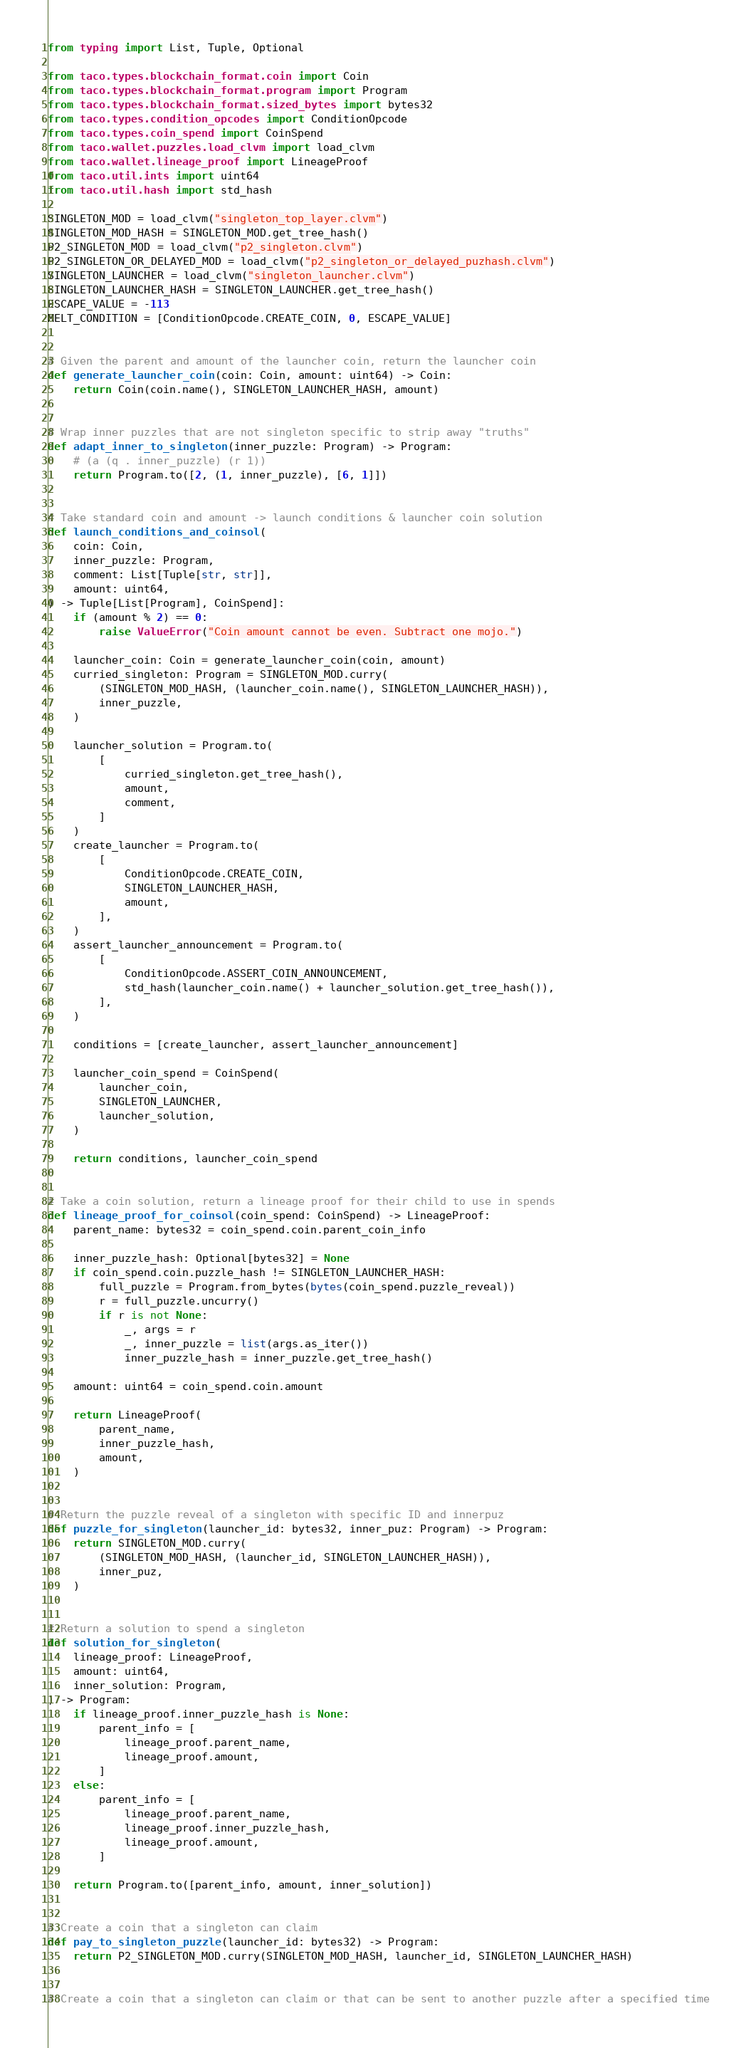Convert code to text. <code><loc_0><loc_0><loc_500><loc_500><_Python_>from typing import List, Tuple, Optional

from taco.types.blockchain_format.coin import Coin
from taco.types.blockchain_format.program import Program
from taco.types.blockchain_format.sized_bytes import bytes32
from taco.types.condition_opcodes import ConditionOpcode
from taco.types.coin_spend import CoinSpend
from taco.wallet.puzzles.load_clvm import load_clvm
from taco.wallet.lineage_proof import LineageProof
from taco.util.ints import uint64
from taco.util.hash import std_hash

SINGLETON_MOD = load_clvm("singleton_top_layer.clvm")
SINGLETON_MOD_HASH = SINGLETON_MOD.get_tree_hash()
P2_SINGLETON_MOD = load_clvm("p2_singleton.clvm")
P2_SINGLETON_OR_DELAYED_MOD = load_clvm("p2_singleton_or_delayed_puzhash.clvm")
SINGLETON_LAUNCHER = load_clvm("singleton_launcher.clvm")
SINGLETON_LAUNCHER_HASH = SINGLETON_LAUNCHER.get_tree_hash()
ESCAPE_VALUE = -113
MELT_CONDITION = [ConditionOpcode.CREATE_COIN, 0, ESCAPE_VALUE]


# Given the parent and amount of the launcher coin, return the launcher coin
def generate_launcher_coin(coin: Coin, amount: uint64) -> Coin:
    return Coin(coin.name(), SINGLETON_LAUNCHER_HASH, amount)


# Wrap inner puzzles that are not singleton specific to strip away "truths"
def adapt_inner_to_singleton(inner_puzzle: Program) -> Program:
    # (a (q . inner_puzzle) (r 1))
    return Program.to([2, (1, inner_puzzle), [6, 1]])


# Take standard coin and amount -> launch conditions & launcher coin solution
def launch_conditions_and_coinsol(
    coin: Coin,
    inner_puzzle: Program,
    comment: List[Tuple[str, str]],
    amount: uint64,
) -> Tuple[List[Program], CoinSpend]:
    if (amount % 2) == 0:
        raise ValueError("Coin amount cannot be even. Subtract one mojo.")

    launcher_coin: Coin = generate_launcher_coin(coin, amount)
    curried_singleton: Program = SINGLETON_MOD.curry(
        (SINGLETON_MOD_HASH, (launcher_coin.name(), SINGLETON_LAUNCHER_HASH)),
        inner_puzzle,
    )

    launcher_solution = Program.to(
        [
            curried_singleton.get_tree_hash(),
            amount,
            comment,
        ]
    )
    create_launcher = Program.to(
        [
            ConditionOpcode.CREATE_COIN,
            SINGLETON_LAUNCHER_HASH,
            amount,
        ],
    )
    assert_launcher_announcement = Program.to(
        [
            ConditionOpcode.ASSERT_COIN_ANNOUNCEMENT,
            std_hash(launcher_coin.name() + launcher_solution.get_tree_hash()),
        ],
    )

    conditions = [create_launcher, assert_launcher_announcement]

    launcher_coin_spend = CoinSpend(
        launcher_coin,
        SINGLETON_LAUNCHER,
        launcher_solution,
    )

    return conditions, launcher_coin_spend


# Take a coin solution, return a lineage proof for their child to use in spends
def lineage_proof_for_coinsol(coin_spend: CoinSpend) -> LineageProof:
    parent_name: bytes32 = coin_spend.coin.parent_coin_info

    inner_puzzle_hash: Optional[bytes32] = None
    if coin_spend.coin.puzzle_hash != SINGLETON_LAUNCHER_HASH:
        full_puzzle = Program.from_bytes(bytes(coin_spend.puzzle_reveal))
        r = full_puzzle.uncurry()
        if r is not None:
            _, args = r
            _, inner_puzzle = list(args.as_iter())
            inner_puzzle_hash = inner_puzzle.get_tree_hash()

    amount: uint64 = coin_spend.coin.amount

    return LineageProof(
        parent_name,
        inner_puzzle_hash,
        amount,
    )


# Return the puzzle reveal of a singleton with specific ID and innerpuz
def puzzle_for_singleton(launcher_id: bytes32, inner_puz: Program) -> Program:
    return SINGLETON_MOD.curry(
        (SINGLETON_MOD_HASH, (launcher_id, SINGLETON_LAUNCHER_HASH)),
        inner_puz,
    )


# Return a solution to spend a singleton
def solution_for_singleton(
    lineage_proof: LineageProof,
    amount: uint64,
    inner_solution: Program,
) -> Program:
    if lineage_proof.inner_puzzle_hash is None:
        parent_info = [
            lineage_proof.parent_name,
            lineage_proof.amount,
        ]
    else:
        parent_info = [
            lineage_proof.parent_name,
            lineage_proof.inner_puzzle_hash,
            lineage_proof.amount,
        ]

    return Program.to([parent_info, amount, inner_solution])


# Create a coin that a singleton can claim
def pay_to_singleton_puzzle(launcher_id: bytes32) -> Program:
    return P2_SINGLETON_MOD.curry(SINGLETON_MOD_HASH, launcher_id, SINGLETON_LAUNCHER_HASH)


# Create a coin that a singleton can claim or that can be sent to another puzzle after a specified time</code> 